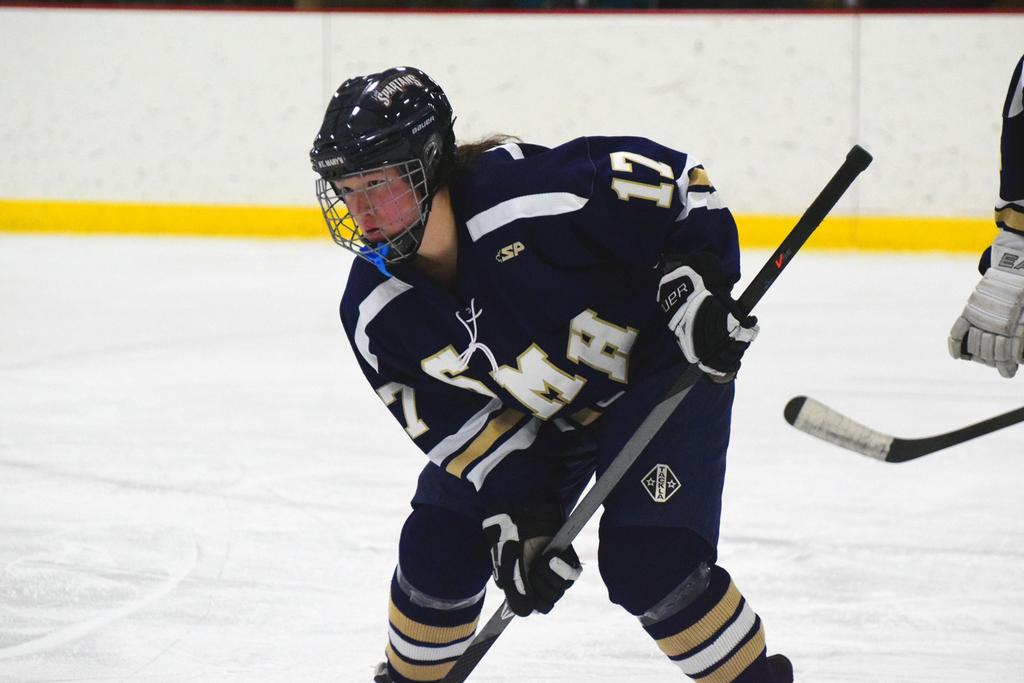Who is present in the image? There is a man in the image. What is the man wearing on his head? The man is wearing a helmet. What is the man wearing on his hands? The man is wearing gloves. What is the man holding in the image? The man is holding a stick. Can you describe the person in the background of the image? There is a person in the background of the image. What type of advertisement is the man teaching in the image? There is no advertisement or teaching activity present in the image. The man is simply wearing a helmet, gloves, and holding a stick. 